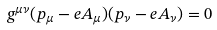<formula> <loc_0><loc_0><loc_500><loc_500>g ^ { \mu \nu } ( p _ { \mu } - e A _ { \mu } ) ( p _ { \nu } - e A _ { \nu } ) = 0</formula> 